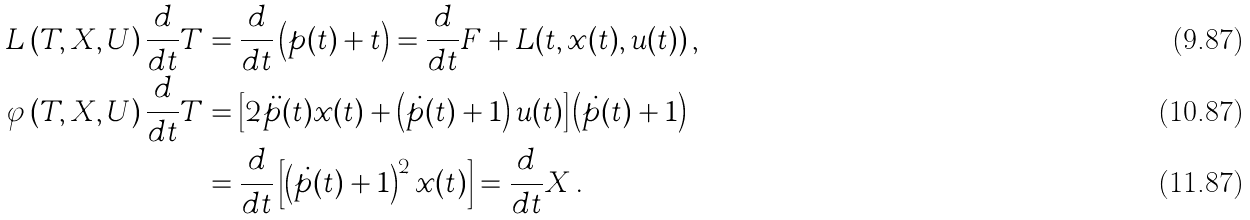<formula> <loc_0><loc_0><loc_500><loc_500>L \left ( T , X , U \right ) \frac { d } { d t } T & = \frac { d } { d t } \left ( p ( t ) + t \right ) = \frac { d } { d t } F + L ( t , x ( t ) , u ( t ) ) \, , \\ \varphi \left ( T , X , U \right ) \frac { d } { d t } T & = \left [ 2 \ddot { p } ( t ) x ( t ) + \left ( \dot { p } ( t ) + 1 \right ) u ( t ) \right ] \left ( \dot { p } ( t ) + 1 \right ) \\ & = \frac { d } { d t } \left [ \left ( \dot { p } ( t ) + 1 \right ) ^ { 2 } x ( t ) \right ] = \frac { d } { d t } X \, .</formula> 